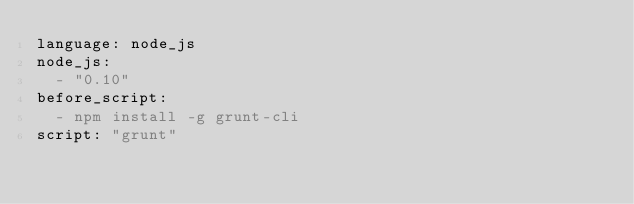<code> <loc_0><loc_0><loc_500><loc_500><_YAML_>language: node_js
node_js:
  - "0.10"
before_script:
  - npm install -g grunt-cli
script: "grunt"</code> 